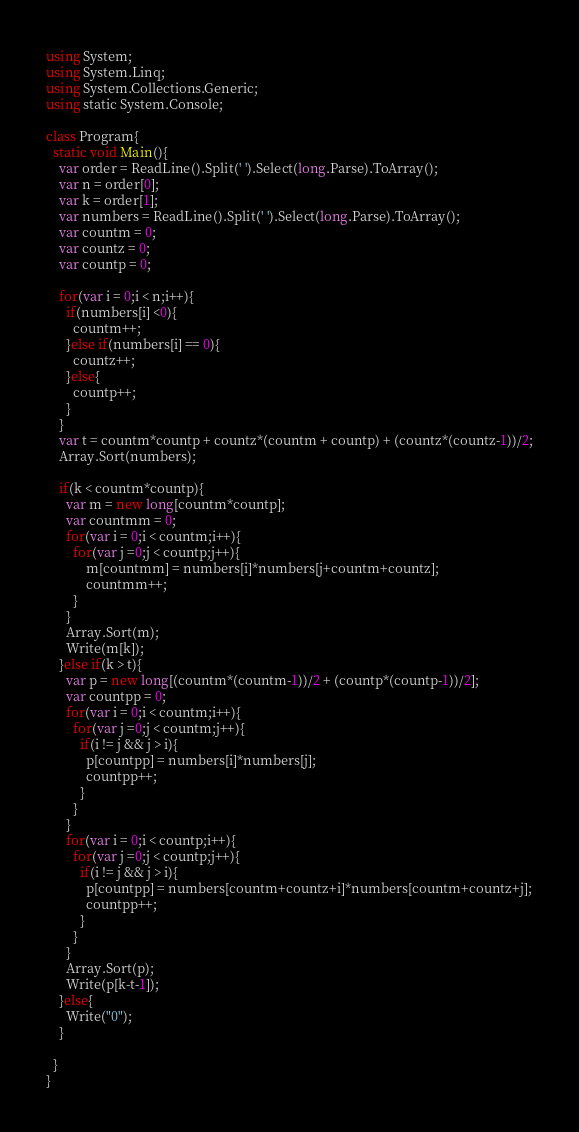Convert code to text. <code><loc_0><loc_0><loc_500><loc_500><_C#_>using System;
using System.Linq;
using System.Collections.Generic;
using static System.Console;
 
class Program{
  static void Main(){
	var order = ReadLine().Split(' ').Select(long.Parse).ToArray();
    var n = order[0];
    var k = order[1];
    var numbers = ReadLine().Split(' ').Select(long.Parse).ToArray();
    var countm = 0;
    var countz = 0;
    var countp = 0;
	
    for(var i = 0;i < n;i++){
      if(numbers[i] <0){
      	countm++;
      }else if(numbers[i] == 0){
        countz++;
      }else{
        countp++;
      }
    } 
    var t = countm*countp + countz*(countm + countp) + (countz*(countz-1))/2;
	Array.Sort(numbers);
    
    if(k < countm*countp){
      var m = new long[countm*countp];
      var countmm = 0; 
      for(var i = 0;i < countm;i++){
      	for(var j =0;j < countp;j++){
            m[countmm] = numbers[i]*numbers[j+countm+countz];
			countmm++;
        }
      }
      Array.Sort(m);
      Write(m[k]);
    }else if(k > t){
      var p = new long[(countm*(countm-1))/2 + (countp*(countp-1))/2];
      var countpp = 0; 
      for(var i = 0;i < countm;i++){
      	for(var j =0;j < countm;j++){
          if(i != j && j > i){
            p[countpp] = numbers[i]*numbers[j];
			countpp++;
          }
        }
      }
      for(var i = 0;i < countp;i++){
      	for(var j =0;j < countp;j++){
          if(i != j && j > i){
            p[countpp] = numbers[countm+countz+i]*numbers[countm+countz+j];
			countpp++;
          }
        }
      }
      Array.Sort(p);
	  Write(p[k-t-1]);
    }else{
	  Write("0");
    }

  }
}</code> 